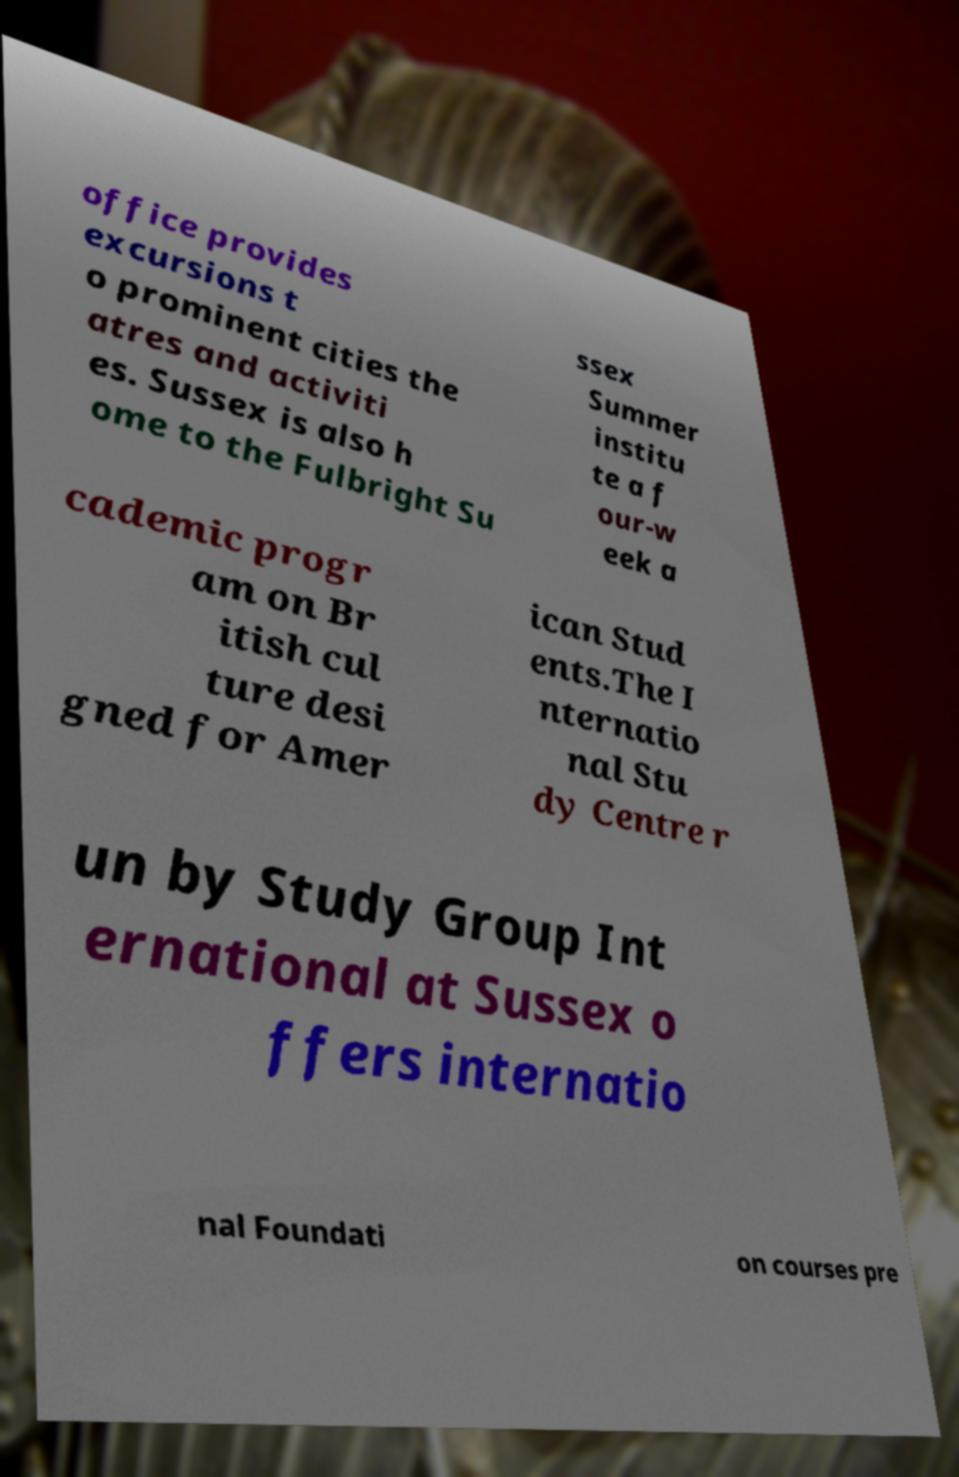For documentation purposes, I need the text within this image transcribed. Could you provide that? office provides excursions t o prominent cities the atres and activiti es. Sussex is also h ome to the Fulbright Su ssex Summer institu te a f our-w eek a cademic progr am on Br itish cul ture desi gned for Amer ican Stud ents.The I nternatio nal Stu dy Centre r un by Study Group Int ernational at Sussex o ffers internatio nal Foundati on courses pre 